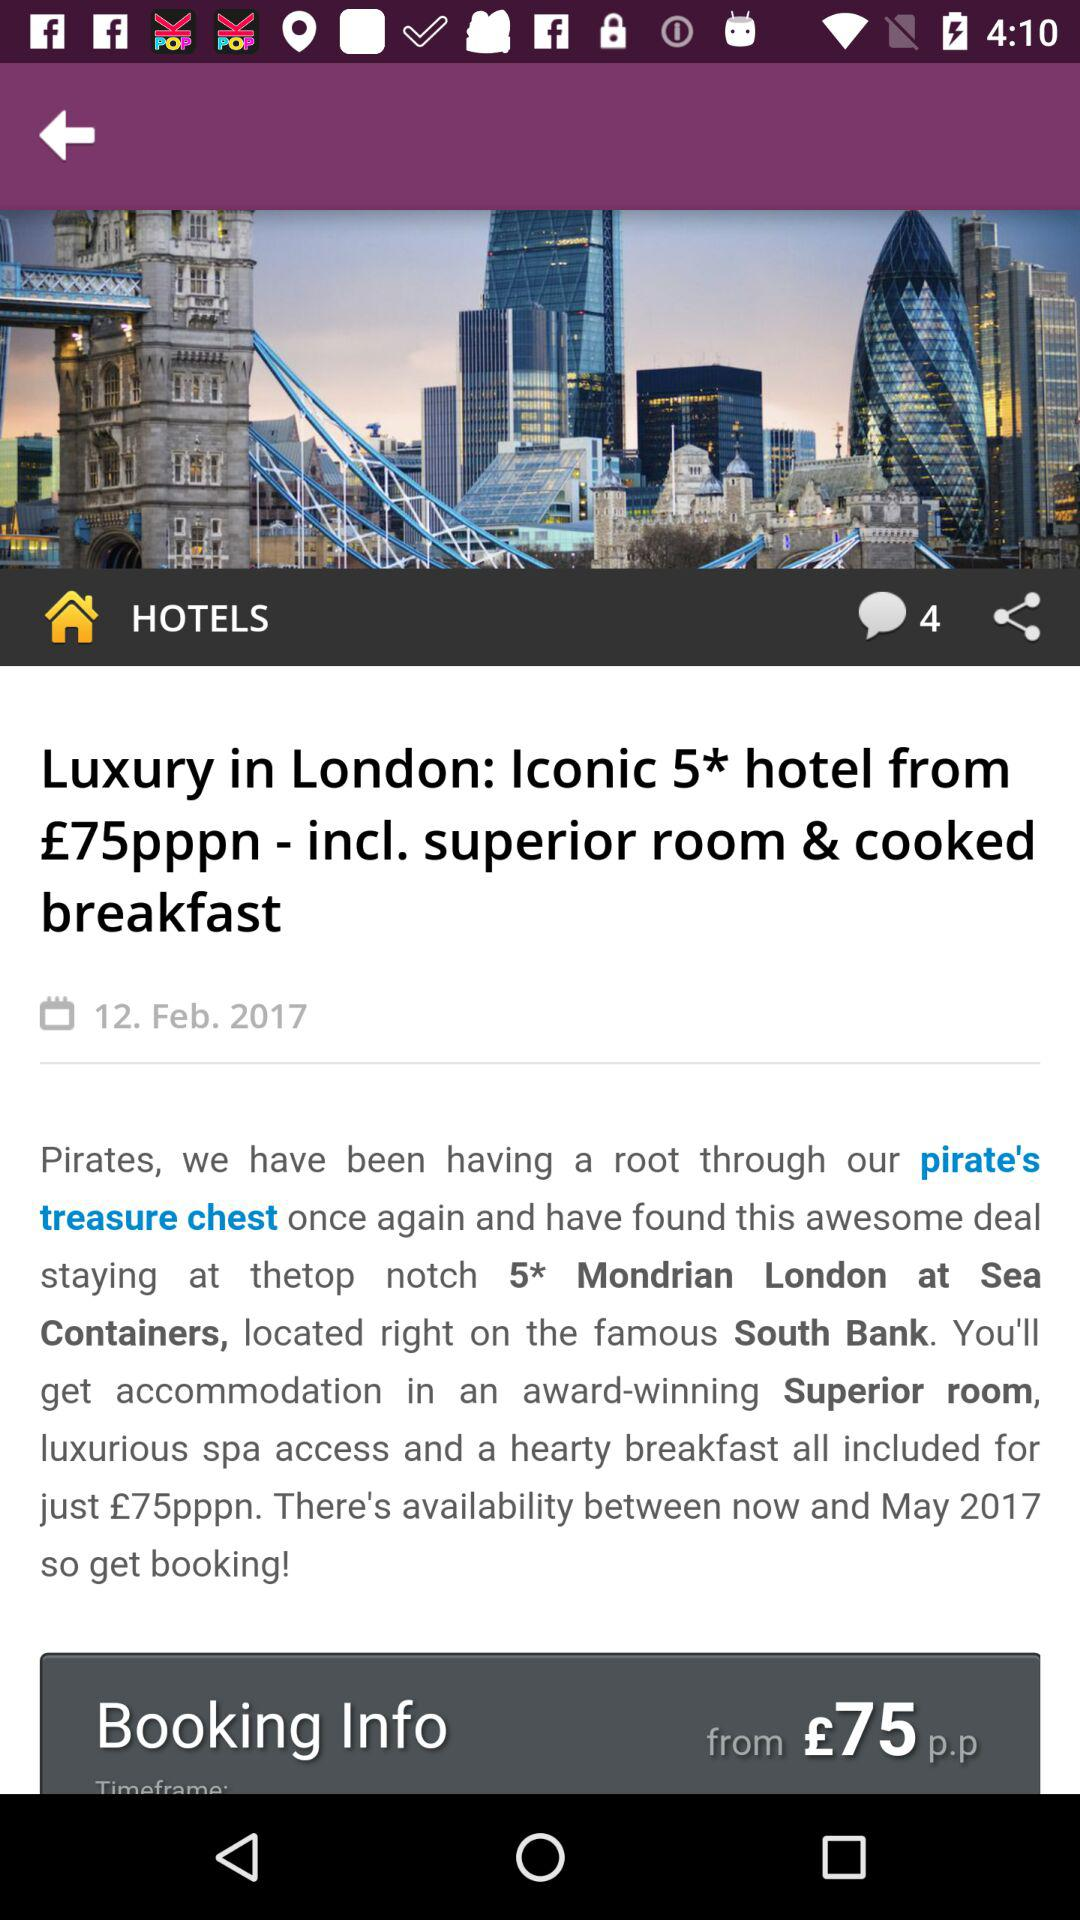What is the headline? The headline is "Luxury in London: Iconic 5* hotel from £75pppn - incl. superior room & cooked breakfast". 